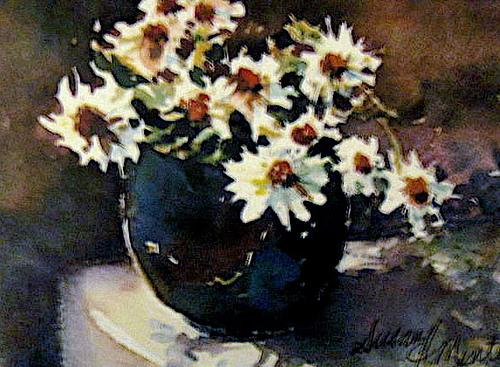What kind of flowers are predominantly shown in the painting? The predominant flowers in the painting are white flowers with red centers and yellow spots. Identify the dominant color of the vase containing the flowers. The dominant color of the vase containing the flowers is black. Describe the setting and background of the painting. The painting features a bouquet of flowers in a vase sitting on a white table, with a blurry, partly dark and blue wall in the background. Count the total number of flowers that are specifically mentioned in the image. There are 10 specific flowers identified in the image. What is the main sentiment conveyed by the image? The main sentiment conveyed by the image is a sense of beauty and tranquility from the delicate flowers in the vase. How many flowers can be identified in the painting, and what colors are present in them? There are several white flowers with red centers and yellow spots, as well as a drooping flower and a red bud. Examine the tablecloth on the table and describe any imperfections or unique features. There is an edge of the white tablecloth visible, and a loose thread can be seen on the cloth. What is the overall quality of the painting in terms of focus and clarity? The overall quality of the painting is blurry, indicating it might be an impressionist or abstract style. Explain any complex reasoning required to understand the relationships between objects in the image. The image includes various objects such as the vase, table, tablecloth, and flowers, with relationships involving containment, support, and surface interactions. Additionally, the artistic elements, such as the blurry style and artist's signature, contribute to the overall context and meaning of the painting. Determine if any objects or subjects in the image are interacting with each other. The flowers interact with the vase by being placed inside it, and the vase is sitting on a table with a tablecloth. 